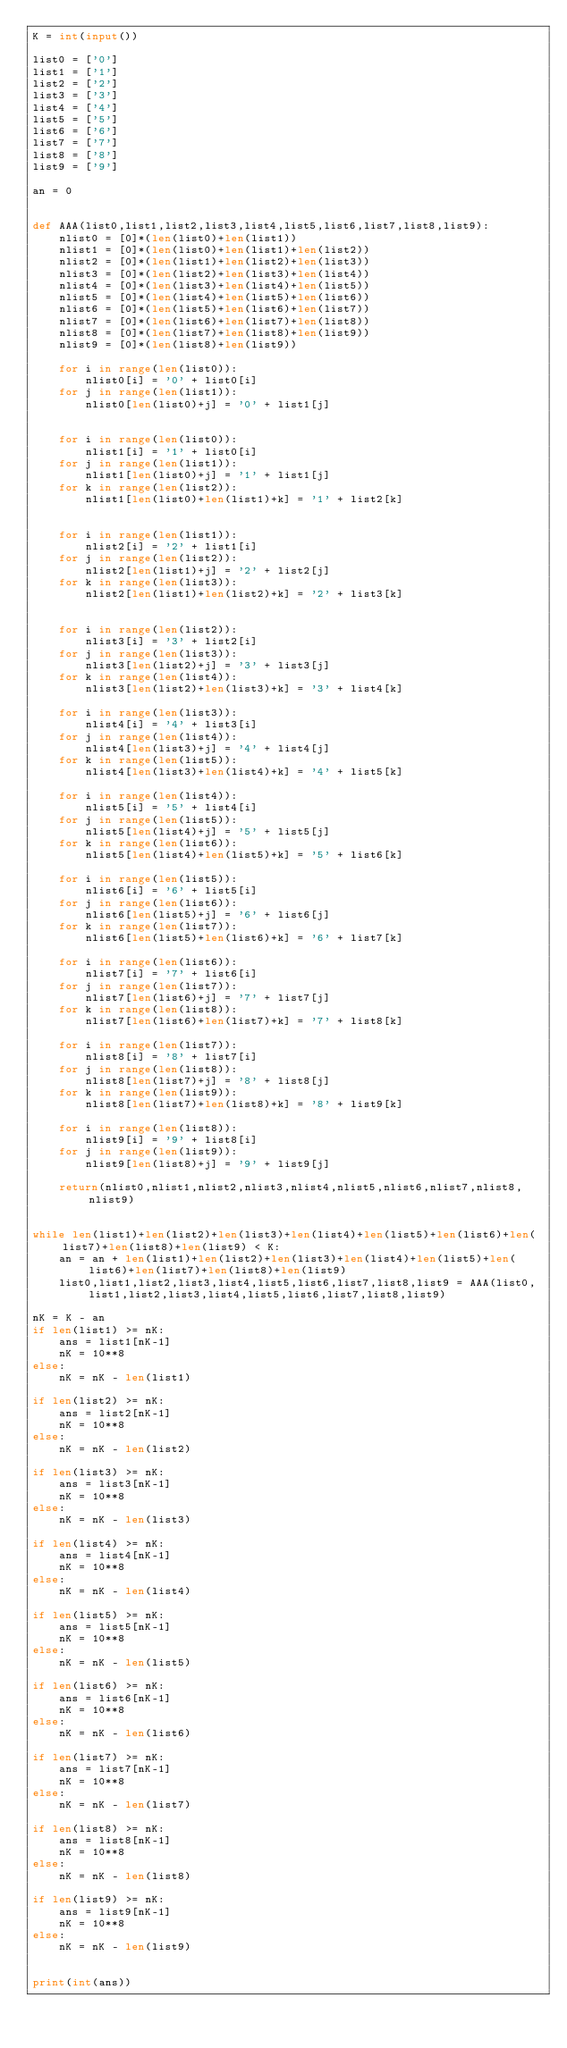<code> <loc_0><loc_0><loc_500><loc_500><_Python_>K = int(input())

list0 = ['0']
list1 = ['1']
list2 = ['2']
list3 = ['3']
list4 = ['4']
list5 = ['5']
list6 = ['6']
list7 = ['7']
list8 = ['8']
list9 = ['9']

an = 0


def AAA(list0,list1,list2,list3,list4,list5,list6,list7,list8,list9):
    nlist0 = [0]*(len(list0)+len(list1))
    nlist1 = [0]*(len(list0)+len(list1)+len(list2))
    nlist2 = [0]*(len(list1)+len(list2)+len(list3))
    nlist3 = [0]*(len(list2)+len(list3)+len(list4))
    nlist4 = [0]*(len(list3)+len(list4)+len(list5))
    nlist5 = [0]*(len(list4)+len(list5)+len(list6))
    nlist6 = [0]*(len(list5)+len(list6)+len(list7))
    nlist7 = [0]*(len(list6)+len(list7)+len(list8))
    nlist8 = [0]*(len(list7)+len(list8)+len(list9))
    nlist9 = [0]*(len(list8)+len(list9))
    
    for i in range(len(list0)):
        nlist0[i] = '0' + list0[i]
    for j in range(len(list1)):
        nlist0[len(list0)+j] = '0' + list1[j]
        
        
    for i in range(len(list0)):
        nlist1[i] = '1' + list0[i]
    for j in range(len(list1)):
        nlist1[len(list0)+j] = '1' + list1[j]
    for k in range(len(list2)):
        nlist1[len(list0)+len(list1)+k] = '1' + list2[k]
        
    
    for i in range(len(list1)):
        nlist2[i] = '2' + list1[i]
    for j in range(len(list2)):
        nlist2[len(list1)+j] = '2' + list2[j]
    for k in range(len(list3)):
        nlist2[len(list1)+len(list2)+k] = '2' + list3[k]
        

    for i in range(len(list2)):
        nlist3[i] = '3' + list2[i]
    for j in range(len(list3)):
        nlist3[len(list2)+j] = '3' + list3[j]
    for k in range(len(list4)):
        nlist3[len(list2)+len(list3)+k] = '3' + list4[k]
    
    for i in range(len(list3)):
        nlist4[i] = '4' + list3[i]
    for j in range(len(list4)):
        nlist4[len(list3)+j] = '4' + list4[j]
    for k in range(len(list5)):
        nlist4[len(list3)+len(list4)+k] = '4' + list5[k]
    
    for i in range(len(list4)):
        nlist5[i] = '5' + list4[i]
    for j in range(len(list5)):
        nlist5[len(list4)+j] = '5' + list5[j]
    for k in range(len(list6)):
        nlist5[len(list4)+len(list5)+k] = '5' + list6[k]
    
    for i in range(len(list5)):
        nlist6[i] = '6' + list5[i]
    for j in range(len(list6)):
        nlist6[len(list5)+j] = '6' + list6[j]
    for k in range(len(list7)):
        nlist6[len(list5)+len(list6)+k] = '6' + list7[k]
    
    for i in range(len(list6)):
        nlist7[i] = '7' + list6[i]
    for j in range(len(list7)):
        nlist7[len(list6)+j] = '7' + list7[j]
    for k in range(len(list8)):
        nlist7[len(list6)+len(list7)+k] = '7' + list8[k]
    
    for i in range(len(list7)):
        nlist8[i] = '8' + list7[i]
    for j in range(len(list8)):
        nlist8[len(list7)+j] = '8' + list8[j]
    for k in range(len(list9)):
        nlist8[len(list7)+len(list8)+k] = '8' + list9[k]
    
    for i in range(len(list8)):
        nlist9[i] = '9' + list8[i]
    for j in range(len(list9)):
        nlist9[len(list8)+j] = '9' + list9[j]
        
    return(nlist0,nlist1,nlist2,nlist3,nlist4,nlist5,nlist6,nlist7,nlist8,nlist9)


while len(list1)+len(list2)+len(list3)+len(list4)+len(list5)+len(list6)+len(list7)+len(list8)+len(list9) < K:
    an = an + len(list1)+len(list2)+len(list3)+len(list4)+len(list5)+len(list6)+len(list7)+len(list8)+len(list9)
    list0,list1,list2,list3,list4,list5,list6,list7,list8,list9 = AAA(list0,list1,list2,list3,list4,list5,list6,list7,list8,list9)

nK = K - an
if len(list1) >= nK:
    ans = list1[nK-1]
    nK = 10**8
else:
    nK = nK - len(list1)

if len(list2) >= nK:
    ans = list2[nK-1]
    nK = 10**8
else:
    nK = nK - len(list2)

if len(list3) >= nK:
    ans = list3[nK-1]
    nK = 10**8
else:
    nK = nK - len(list3)

if len(list4) >= nK:
    ans = list4[nK-1]
    nK = 10**8
else:
    nK = nK - len(list4)

if len(list5) >= nK:
    ans = list5[nK-1]
    nK = 10**8
else:
    nK = nK - len(list5)

if len(list6) >= nK:
    ans = list6[nK-1]
    nK = 10**8
else:
    nK = nK - len(list6)
    
if len(list7) >= nK:
    ans = list7[nK-1]
    nK = 10**8
else:
    nK = nK - len(list7)

if len(list8) >= nK:
    ans = list8[nK-1]
    nK = 10**8
else:
    nK = nK - len(list8)

if len(list9) >= nK:
    ans = list9[nK-1]
    nK = 10**8
else:
    nK = nK - len(list9)
    
    
print(int(ans))</code> 